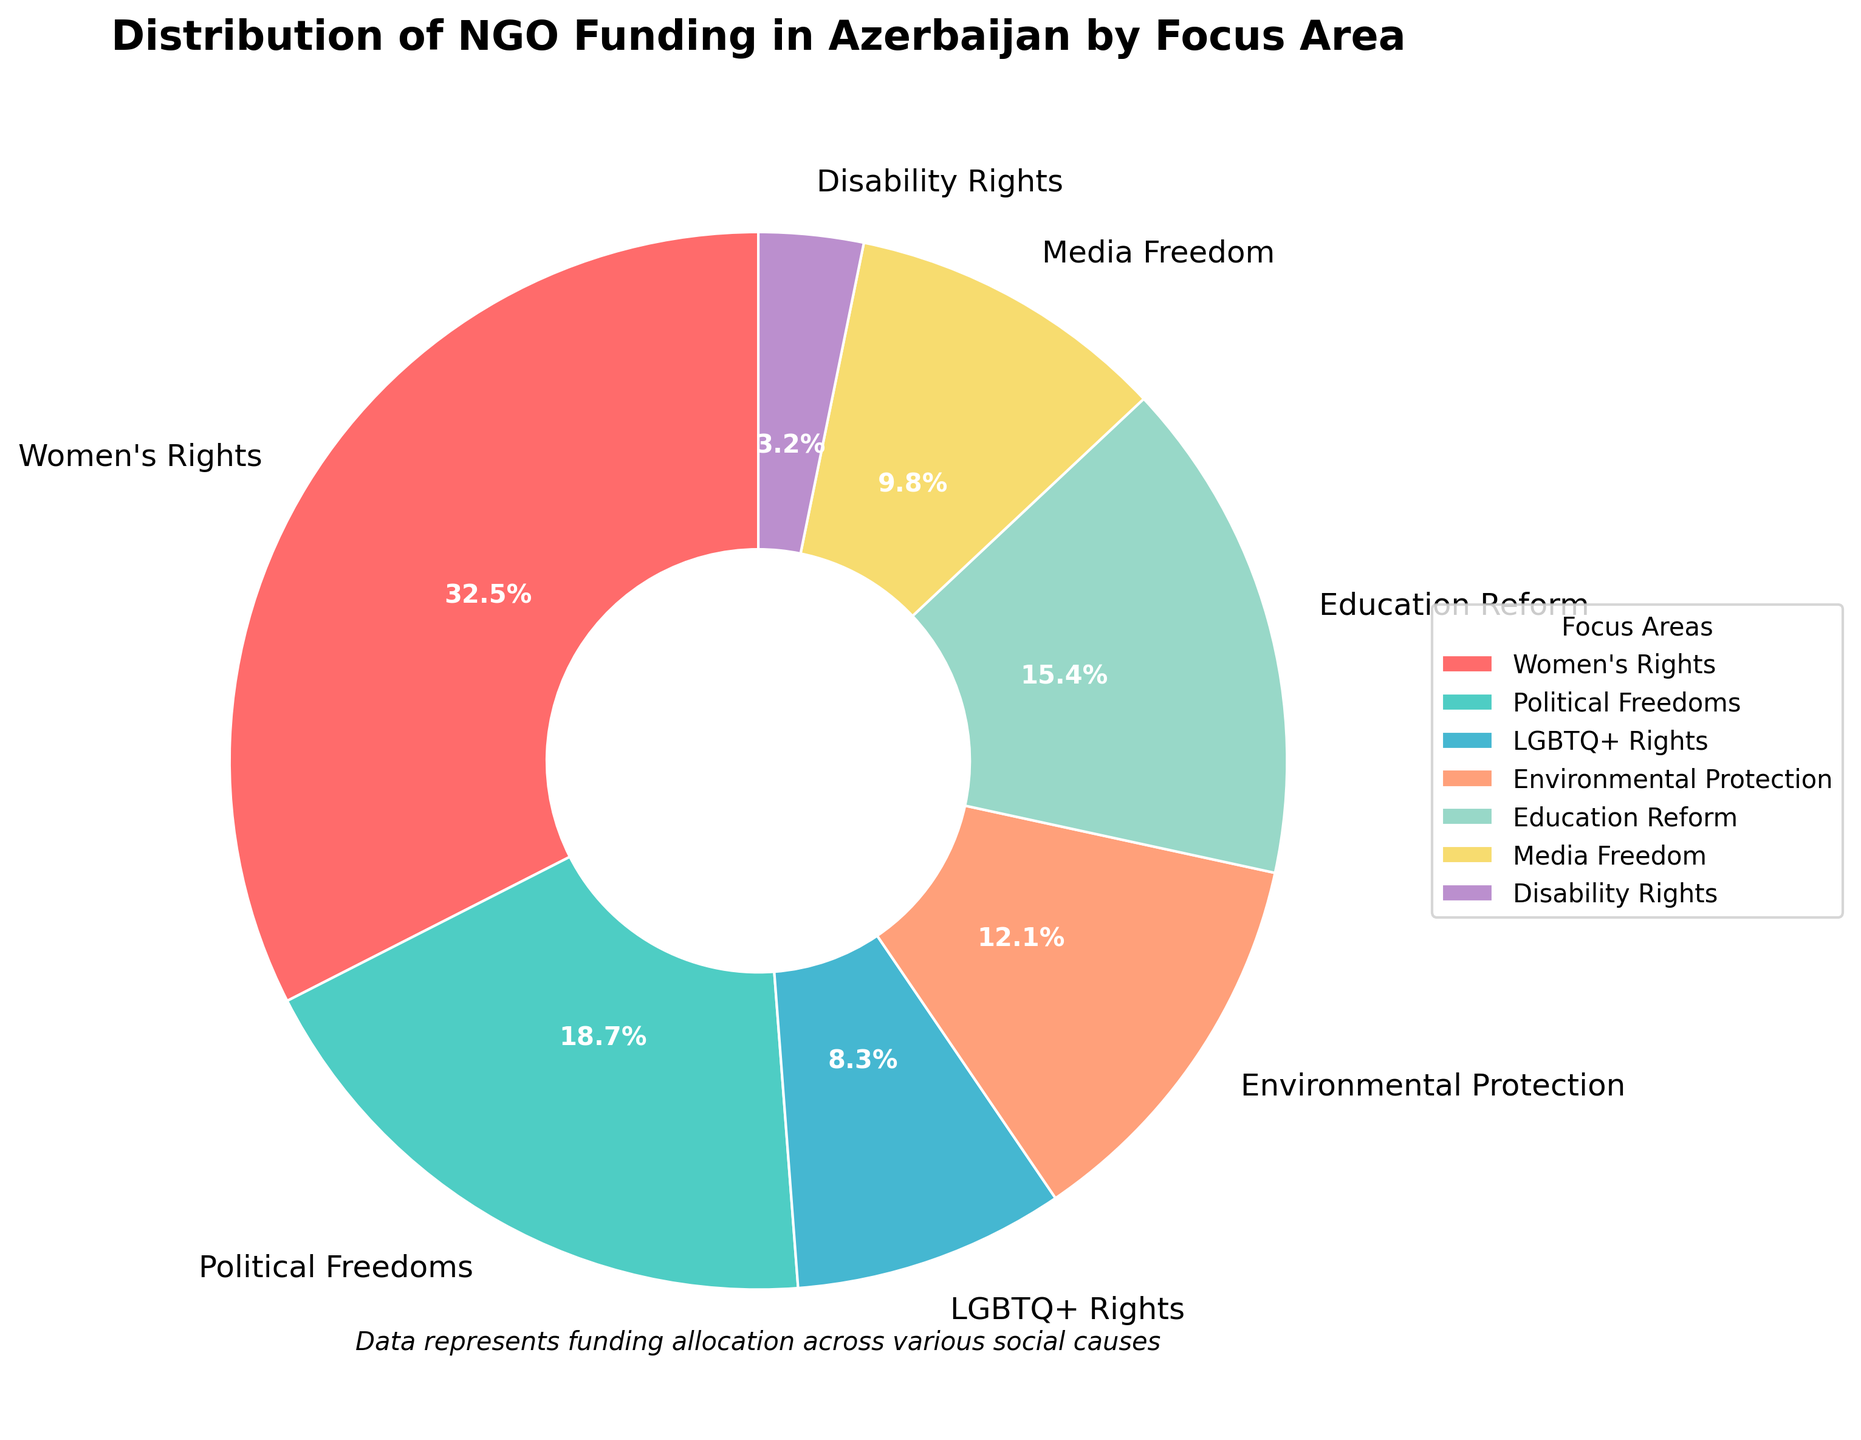Which focus area has the highest percentage of NGO funding? The largest section in the pie chart is red, representing Women's Rights with 32.5%.
Answer: Women's Rights Which focus area receives the least funding? The smallest section in the pie chart is light purple, which represents Disability Rights with 3.2%.
Answer: Disability Rights Compare the funding for Political Freedoms and Media Freedom. Which is higher and by how much? Political Freedoms get 18.7% while Media Freedom gets 9.8%. The difference is 18.7% - 9.8%.
Answer: Political Freedoms by 8.9% What is the combined funding percentage of Women's Rights and LGBTQ+ Rights? Women's Rights get 32.5% and LGBTQ+ Rights get 8.3%. The combined funding is 32.5% + 8.3%.
Answer: 40.8% What fraction of the total funding is allocated to Environmental Protection, rounded to two digits after the decimal point? Environmental Protection receives 12.1%. As a fraction of the whole (100%), it is 12.1/100 = 0.121.
Answer: 0.12 How much more funding percentage does Education Reform receive compared to Disability Rights? Education Reform receives 15.4% while Disability Rights receives 3.2%. The difference is 15.4% - 3.2%.
Answer: 12.2% Is the funding percentage for LGBTQ+ Rights greater than, less than, or equal to the funding percentage for Media Freedom? LGBTQ+ Rights have 8.3% and Media Freedom has 9.8%. Therefore, 8.3% < 9.8%.
Answer: Less than How does the funding for Political Freedoms compare to the total funding for women's rights and LGBTQ+ rights combined? Political Freedoms receive 18.7%. Women's Rights and LGBTQ+ Rights together receive 32.5% + 8.3% = 40.8%. Therefore, 18.7% < 40.8%.
Answer: Less than Which color in the pie chart represents Education Reform and what is the associated percentage? The wedge representing Education Reform is light orange and has a label showing 15.4%.
Answer: Light orange, 15.4% 